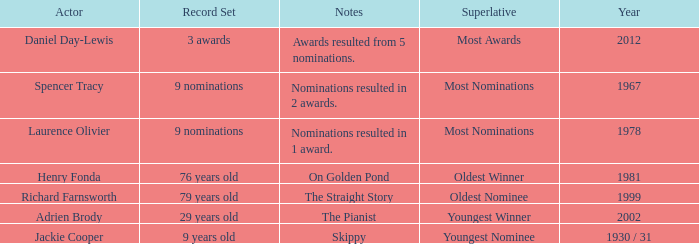In what year had the oldest winner? 1981.0. 